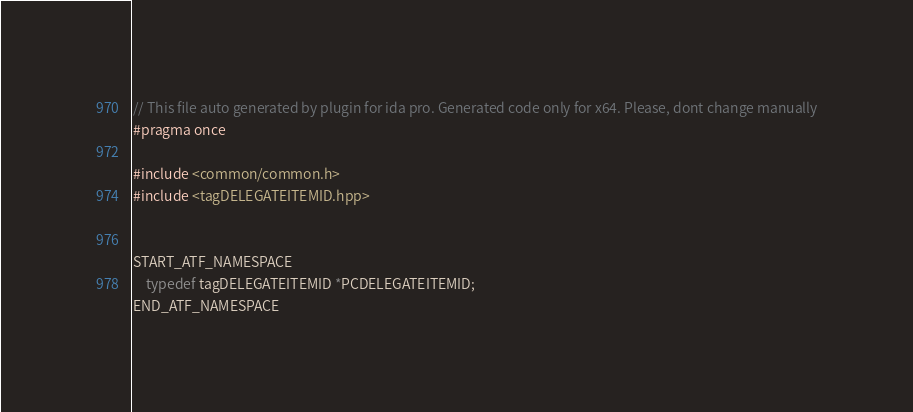Convert code to text. <code><loc_0><loc_0><loc_500><loc_500><_C++_>// This file auto generated by plugin for ida pro. Generated code only for x64. Please, dont change manually
#pragma once

#include <common/common.h>
#include <tagDELEGATEITEMID.hpp>


START_ATF_NAMESPACE
    typedef tagDELEGATEITEMID *PCDELEGATEITEMID;
END_ATF_NAMESPACE
</code> 